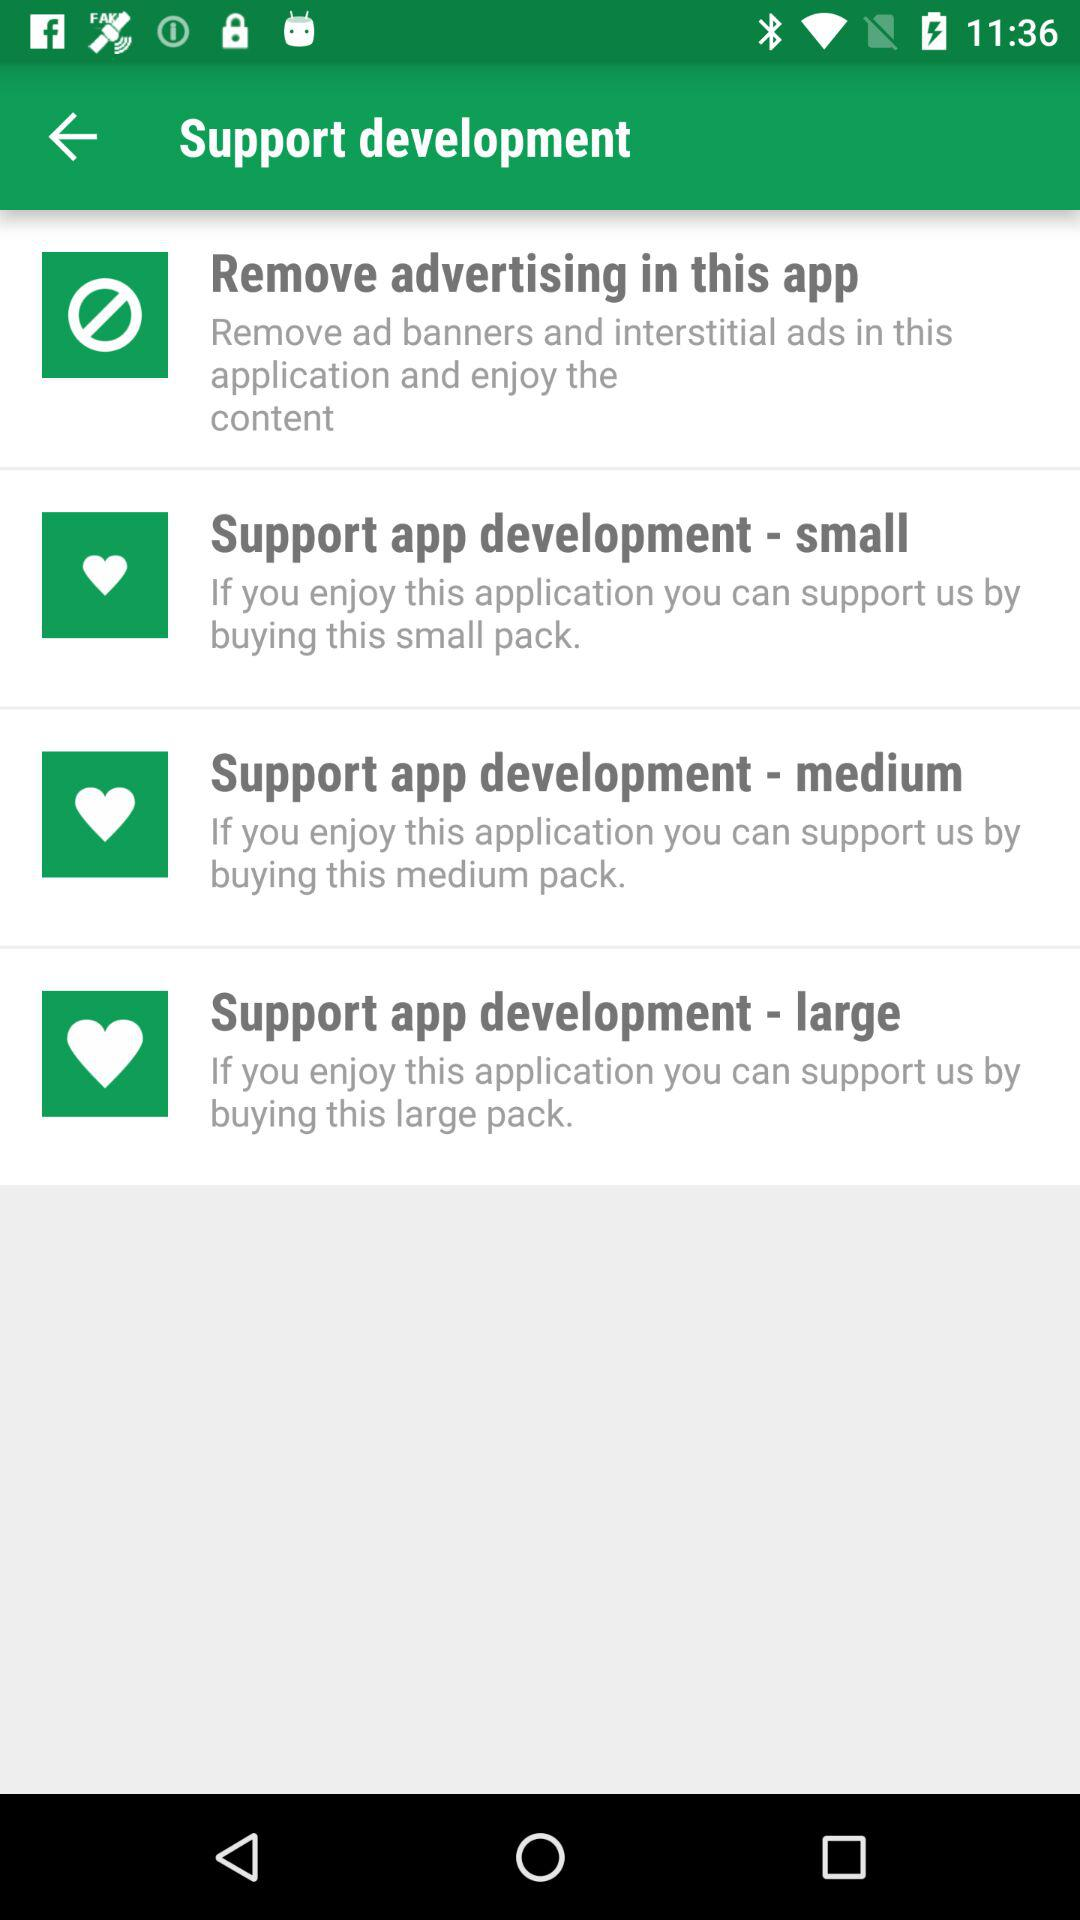How many packs are available to purchase?
Answer the question using a single word or phrase. 3 